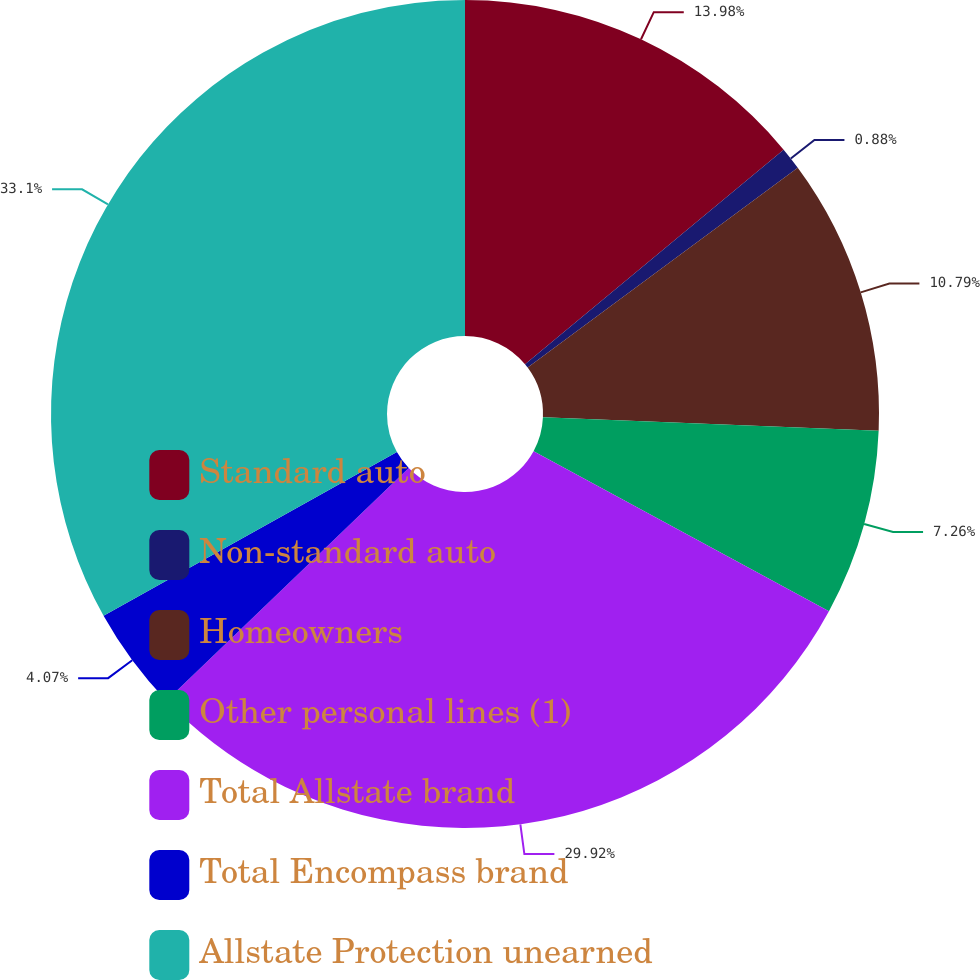Convert chart. <chart><loc_0><loc_0><loc_500><loc_500><pie_chart><fcel>Standard auto<fcel>Non-standard auto<fcel>Homeowners<fcel>Other personal lines (1)<fcel>Total Allstate brand<fcel>Total Encompass brand<fcel>Allstate Protection unearned<nl><fcel>13.98%<fcel>0.88%<fcel>10.79%<fcel>7.26%<fcel>29.92%<fcel>4.07%<fcel>33.11%<nl></chart> 